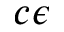<formula> <loc_0><loc_0><loc_500><loc_500>c \epsilon</formula> 